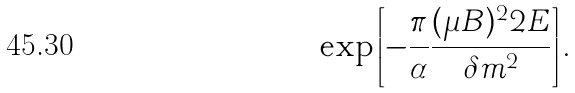Convert formula to latex. <formula><loc_0><loc_0><loc_500><loc_500>\exp \left [ - \frac { \pi } { \alpha } \frac { ( \mu B ) ^ { 2 } 2 E } { \delta m ^ { 2 } } \right ] .</formula> 